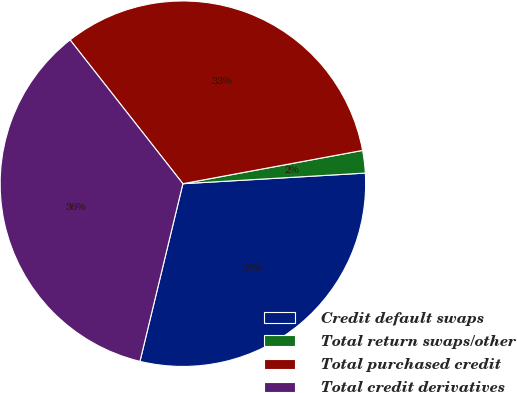Convert chart to OTSL. <chart><loc_0><loc_0><loc_500><loc_500><pie_chart><fcel>Credit default swaps<fcel>Total return swaps/other<fcel>Total purchased credit<fcel>Total credit derivatives<nl><fcel>29.7%<fcel>1.99%<fcel>32.67%<fcel>35.64%<nl></chart> 